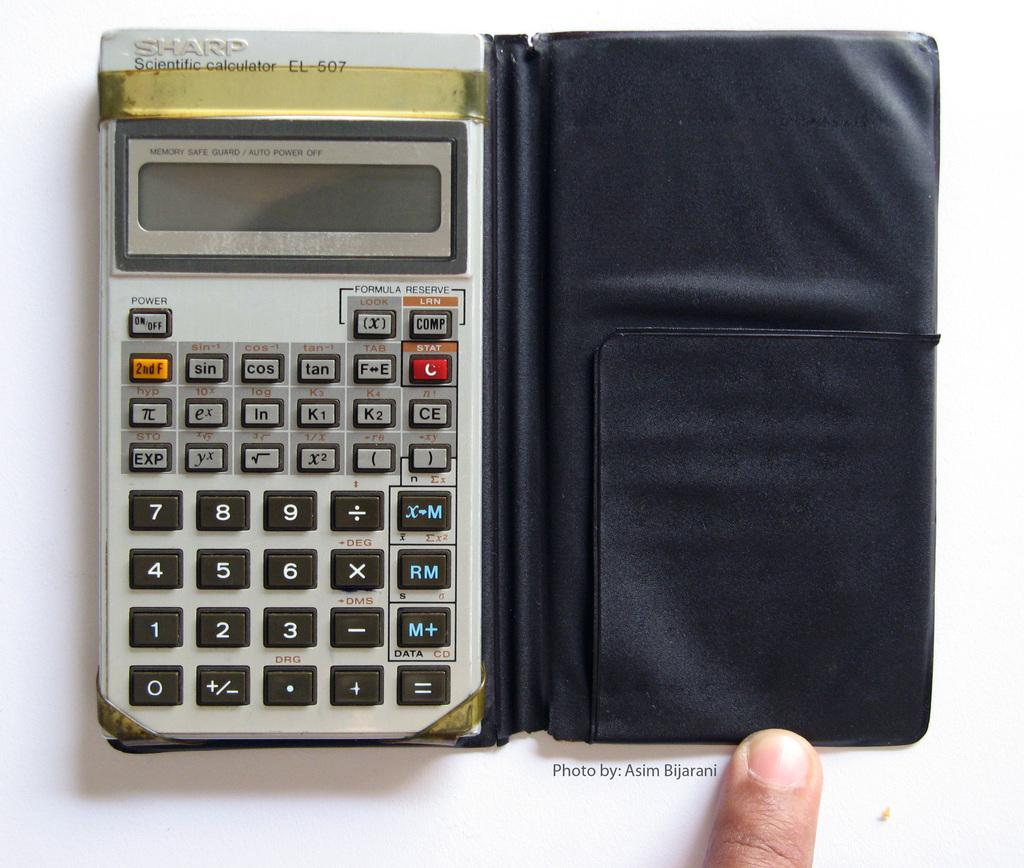<image>
Relay a brief, clear account of the picture shown. Sharp scientific calculators are useful for a variety of advanced mathematical functions. 